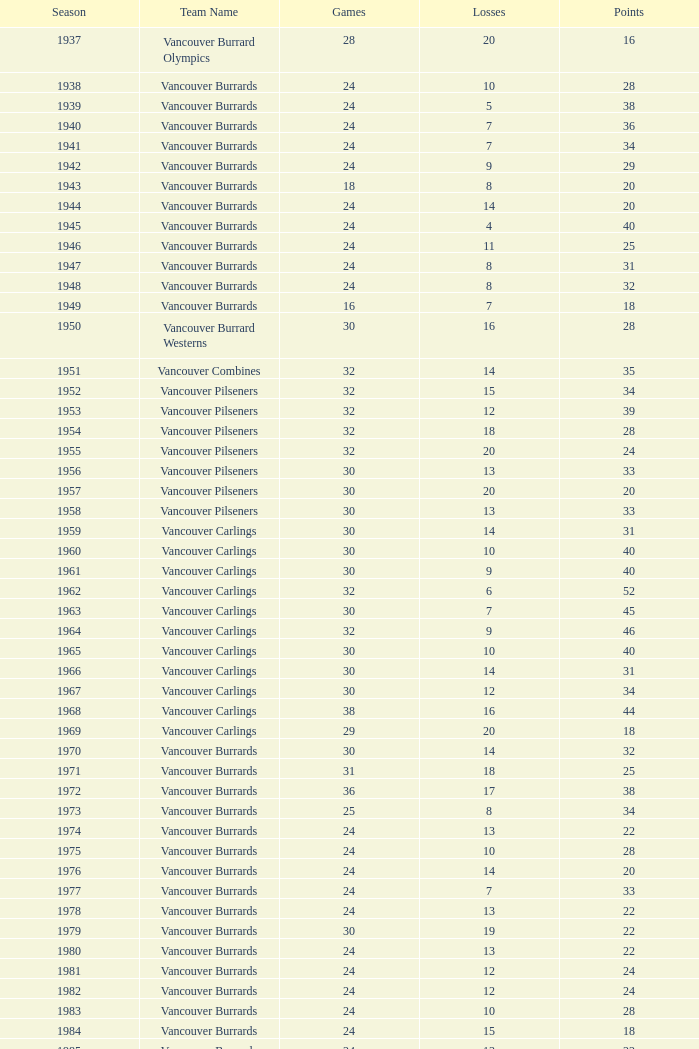With fewer than 8 losses and fewer than 24 games played, what is the least amount of points the vancouver burrards can achieve? 18.0. 